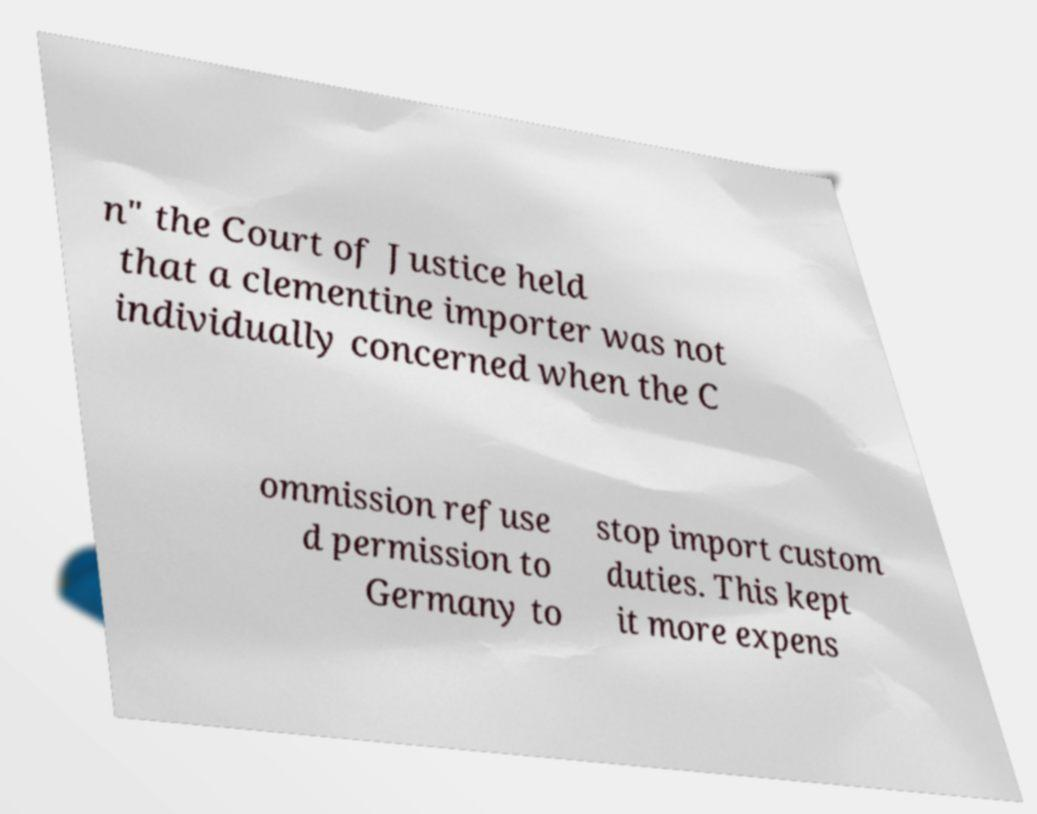Please read and relay the text visible in this image. What does it say? n" the Court of Justice held that a clementine importer was not individually concerned when the C ommission refuse d permission to Germany to stop import custom duties. This kept it more expens 